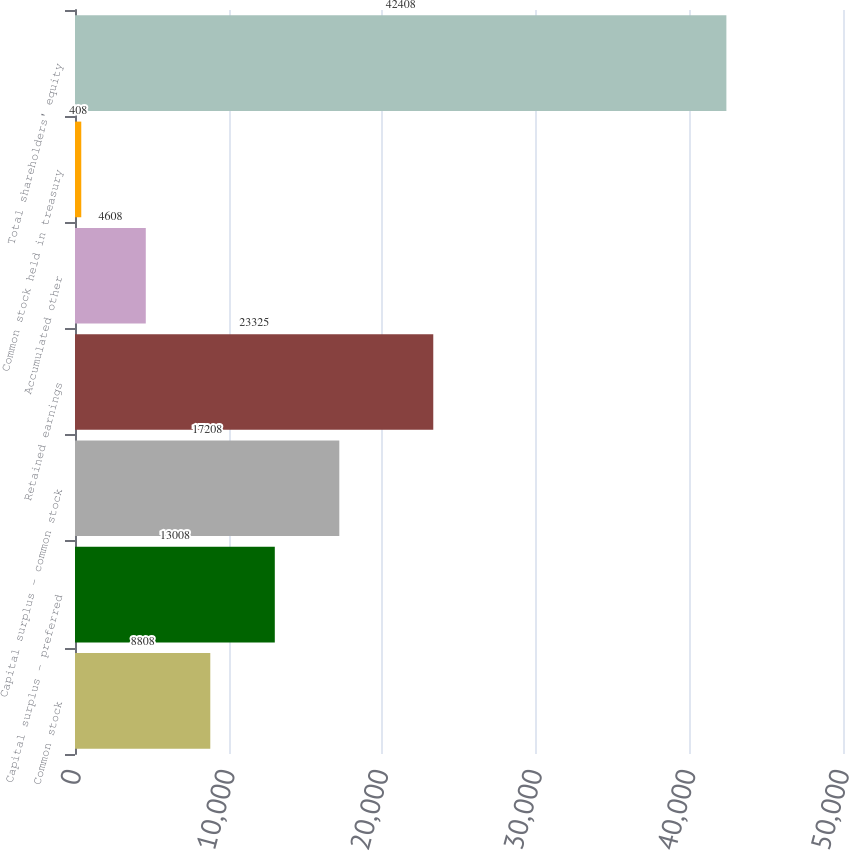<chart> <loc_0><loc_0><loc_500><loc_500><bar_chart><fcel>Common stock<fcel>Capital surplus - preferred<fcel>Capital surplus - common stock<fcel>Retained earnings<fcel>Accumulated other<fcel>Common stock held in treasury<fcel>Total shareholders' equity<nl><fcel>8808<fcel>13008<fcel>17208<fcel>23325<fcel>4608<fcel>408<fcel>42408<nl></chart> 